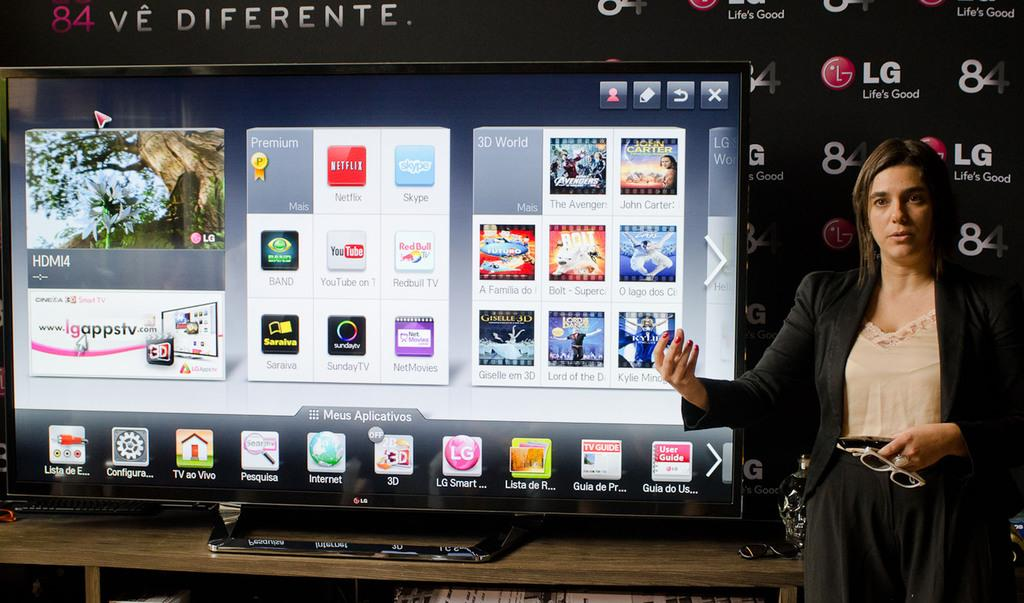<image>
Offer a succinct explanation of the picture presented. A woman stands next to a display reading HDMI4. 